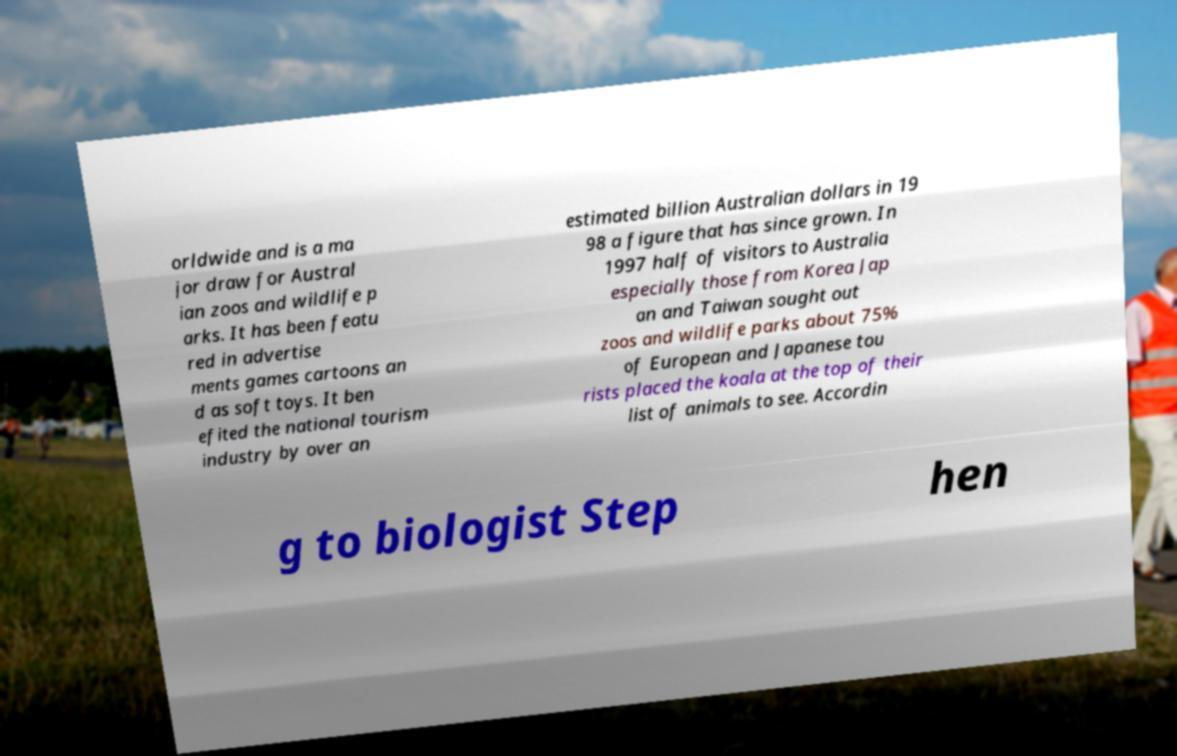Can you read and provide the text displayed in the image?This photo seems to have some interesting text. Can you extract and type it out for me? orldwide and is a ma jor draw for Austral ian zoos and wildlife p arks. It has been featu red in advertise ments games cartoons an d as soft toys. It ben efited the national tourism industry by over an estimated billion Australian dollars in 19 98 a figure that has since grown. In 1997 half of visitors to Australia especially those from Korea Jap an and Taiwan sought out zoos and wildlife parks about 75% of European and Japanese tou rists placed the koala at the top of their list of animals to see. Accordin g to biologist Step hen 